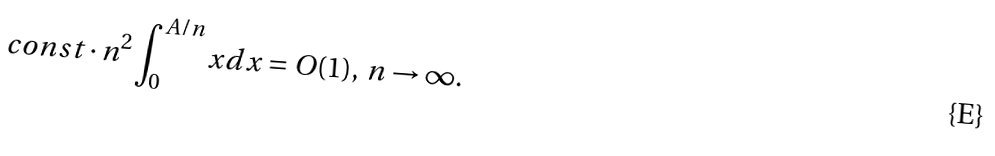<formula> <loc_0><loc_0><loc_500><loc_500>c o n s t \cdot n ^ { 2 } \int _ { 0 } ^ { A / n } x d x = O ( 1 ) , \, n \rightarrow \infty .</formula> 